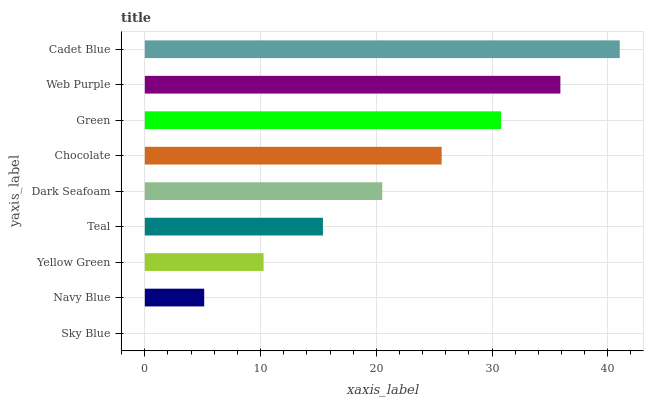Is Sky Blue the minimum?
Answer yes or no. Yes. Is Cadet Blue the maximum?
Answer yes or no. Yes. Is Navy Blue the minimum?
Answer yes or no. No. Is Navy Blue the maximum?
Answer yes or no. No. Is Navy Blue greater than Sky Blue?
Answer yes or no. Yes. Is Sky Blue less than Navy Blue?
Answer yes or no. Yes. Is Sky Blue greater than Navy Blue?
Answer yes or no. No. Is Navy Blue less than Sky Blue?
Answer yes or no. No. Is Dark Seafoam the high median?
Answer yes or no. Yes. Is Dark Seafoam the low median?
Answer yes or no. Yes. Is Teal the high median?
Answer yes or no. No. Is Chocolate the low median?
Answer yes or no. No. 